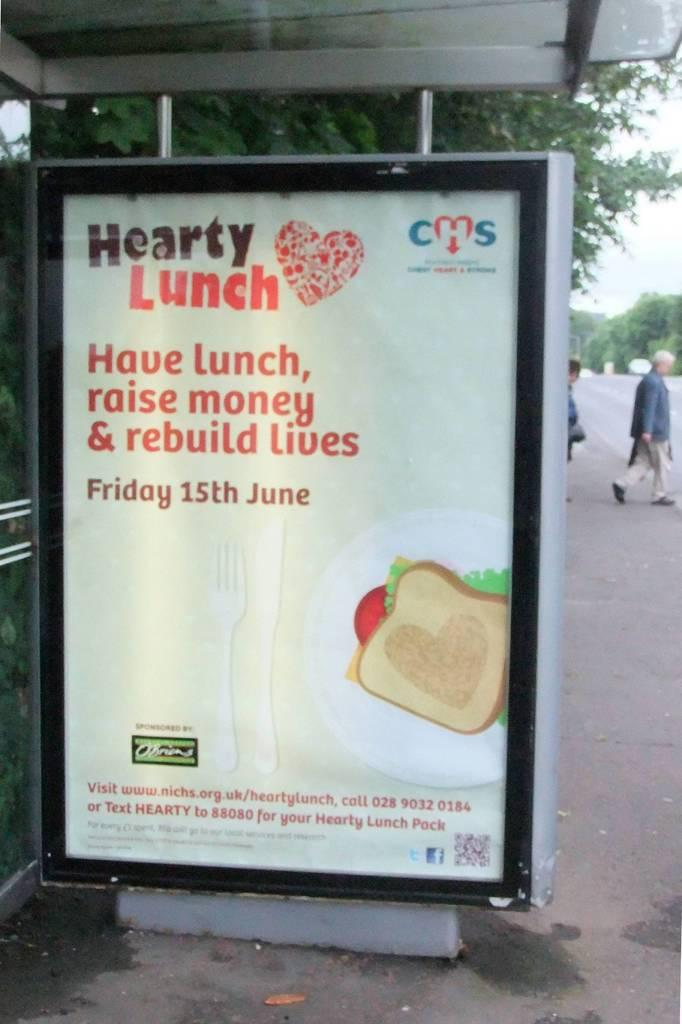<image>
Create a compact narrative representing the image presented. A billboard sign that has a sandwich on it and says Hearty Lunch at the top. 